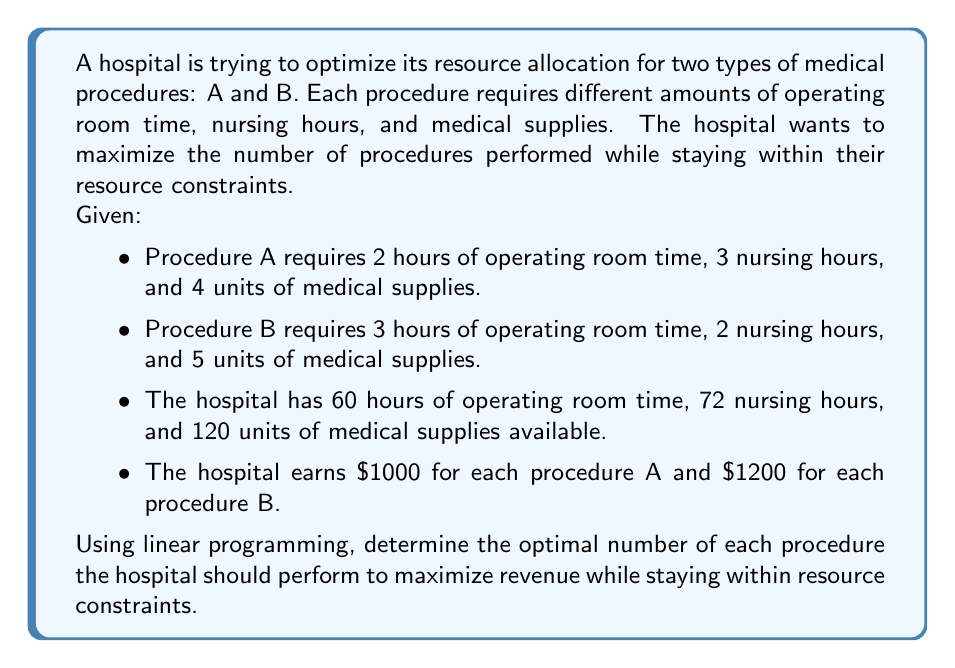Solve this math problem. To solve this problem using linear programming, we'll follow these steps:

1. Define variables:
Let $x$ be the number of procedure A performed
Let $y$ be the number of procedure B performed

2. Set up the objective function:
Maximize $Z = 1000x + 1200y$

3. Define constraints:
Operating room time: $2x + 3y \leq 60$
Nursing hours: $3x + 2y \leq 72$
Medical supplies: $4x + 5y \leq 120$
Non-negativity: $x \geq 0, y \geq 0$

4. Solve using the graphical method:

First, we'll plot the constraints:

$$
\begin{aligned}
2x + 3y &= 60 \\
3x + 2y &= 72 \\
4x + 5y &= 120
\end{aligned}
$$

[asy]
size(200,200);
import graph;

// Define axes
xaxis("x", 0, 40);
yaxis("y", 0, 40);

// Plot constraints
draw((0,20)--(30,0), blue);
draw((0,36)--(24,0), red);
draw((0,24)--(30,0), green);

// Shade feasible region
fill((0,0)--(0,20)--(20,0)--cycle, gray(0.8));

// Label lines
label("2x + 3y = 60", (15,10), blue);
label("3x + 2y = 72", (12,18), red);
label("4x + 5y = 120", (15,6), green);

// Label corner points
dot((0,20));
dot((24,0));
dot((0,36));
dot((30,0));
dot((20,0));
[/asy]

The feasible region is the shaded area. The optimal solution will be at one of the corner points of this region.

5. Evaluate the objective function at each corner point:

(0, 0): $Z = 0$
(0, 20): $Z = 24000$
(20, 0): $Z = 20000$
(12, 12): $Z = 26400$

6. The optimal solution is at the point (12, 12), which gives the maximum value for Z.
Answer: The hospital should perform 12 procedures of type A and 12 procedures of type B to maximize revenue at $26,400 while staying within resource constraints. 